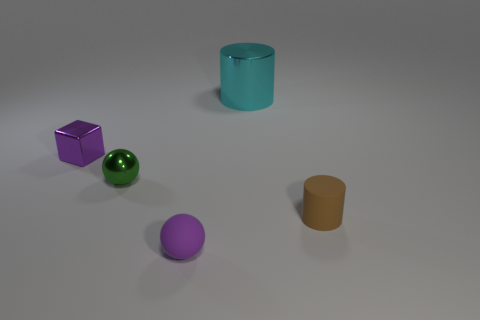There is a tiny thing that is the same color as the tiny cube; what material is it?
Give a very brief answer. Rubber. Do the ball behind the brown thing and the cyan metal cylinder have the same size?
Give a very brief answer. No. What number of big things are on the left side of the large shiny cylinder that is to the right of the tiny rubber thing that is on the left side of the tiny brown thing?
Give a very brief answer. 0. What number of purple objects are big cylinders or tiny matte objects?
Your response must be concise. 1. What color is the small cube that is the same material as the large object?
Ensure brevity in your answer.  Purple. Is there anything else that is the same size as the cyan object?
Your response must be concise. No. What number of small things are gray matte spheres or green metallic objects?
Offer a terse response. 1. Is the number of tiny green objects less than the number of cyan blocks?
Keep it short and to the point. No. The small metal thing that is the same shape as the purple rubber thing is what color?
Offer a very short reply. Green. Is there any other thing that has the same shape as the green object?
Provide a short and direct response. Yes. 